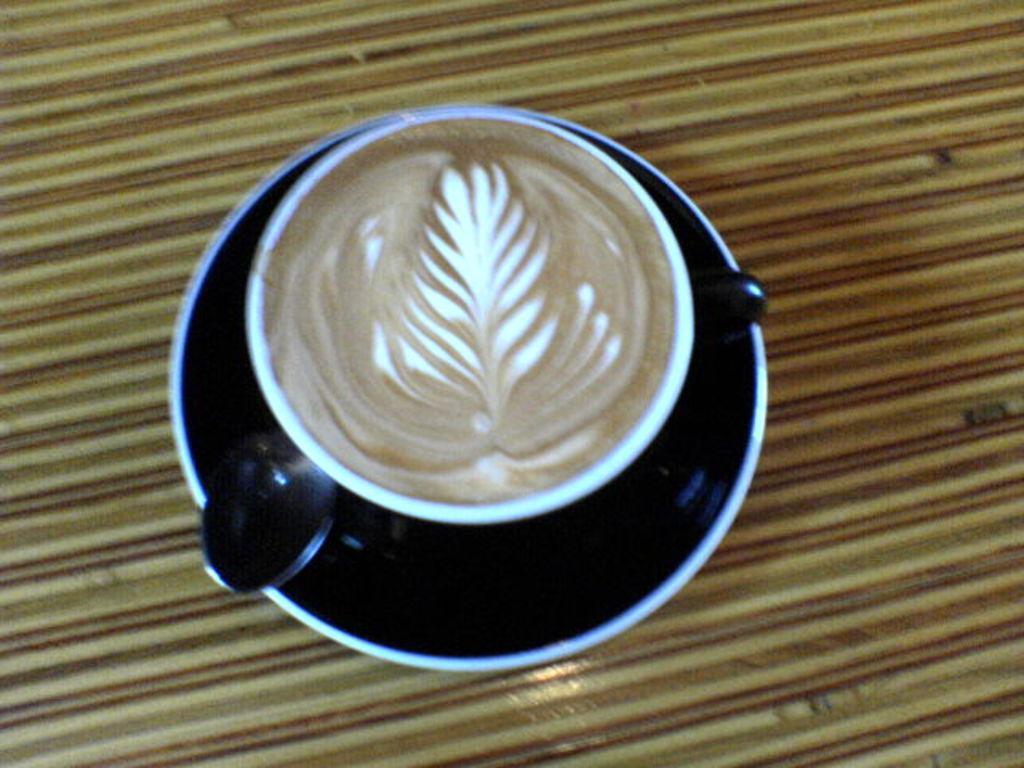In one or two sentences, can you explain what this image depicts? In this image I see the black saucer and I see the white cup in which there is coffee and I see the spoon over here and I see the brown color surface. 